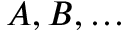Convert formula to latex. <formula><loc_0><loc_0><loc_500><loc_500>A , B , \dots</formula> 